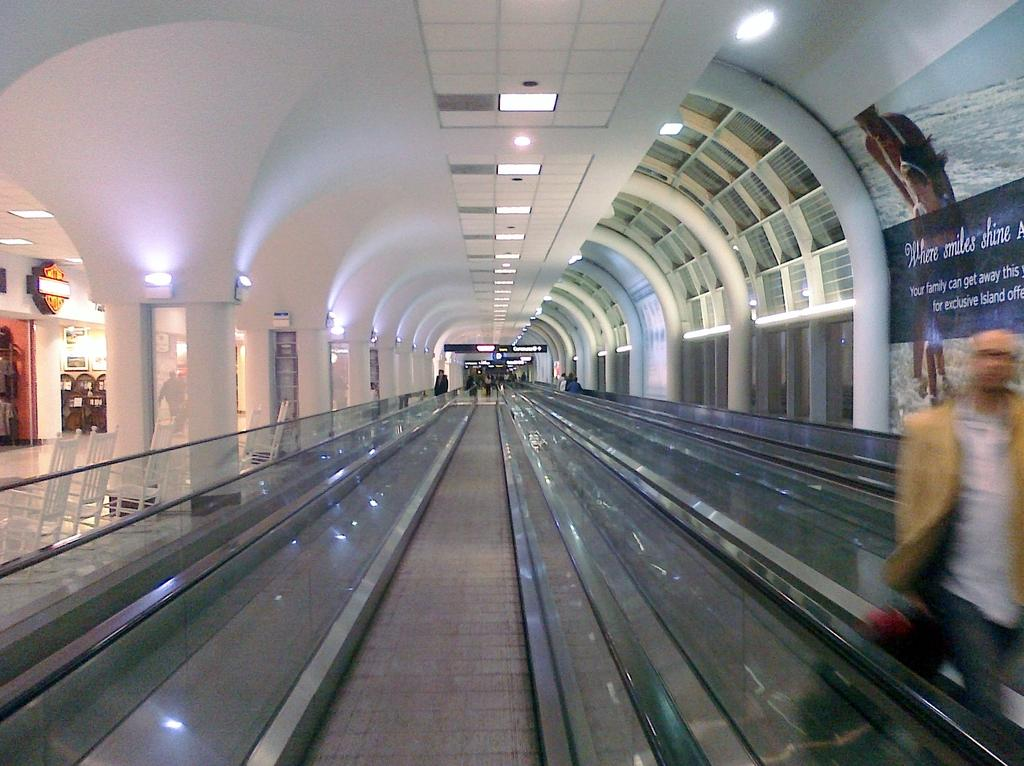<image>
Present a compact description of the photo's key features. A series of moving walkways is in the center while a banner to the right advertises where smiles shine. 